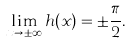<formula> <loc_0><loc_0><loc_500><loc_500>\lim _ { x \rightarrow \pm \infty } h ( x ) = \pm \frac { \pi } { 2 } .</formula> 